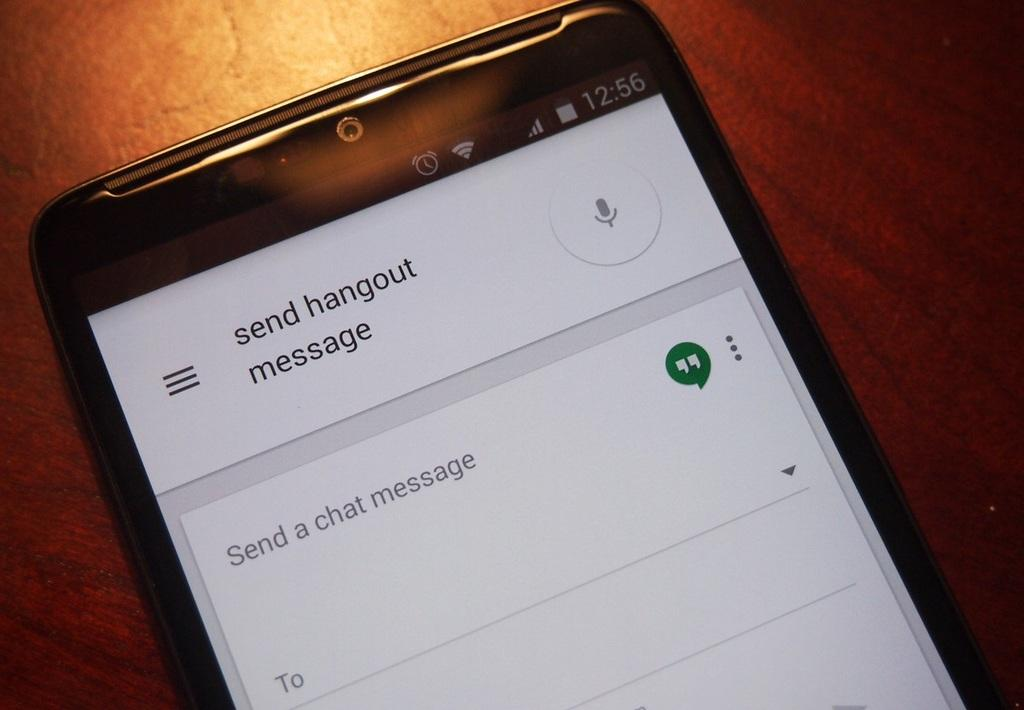<image>
Create a compact narrative representing the image presented. a close up of a cell phone display for SEND Hangout Message 